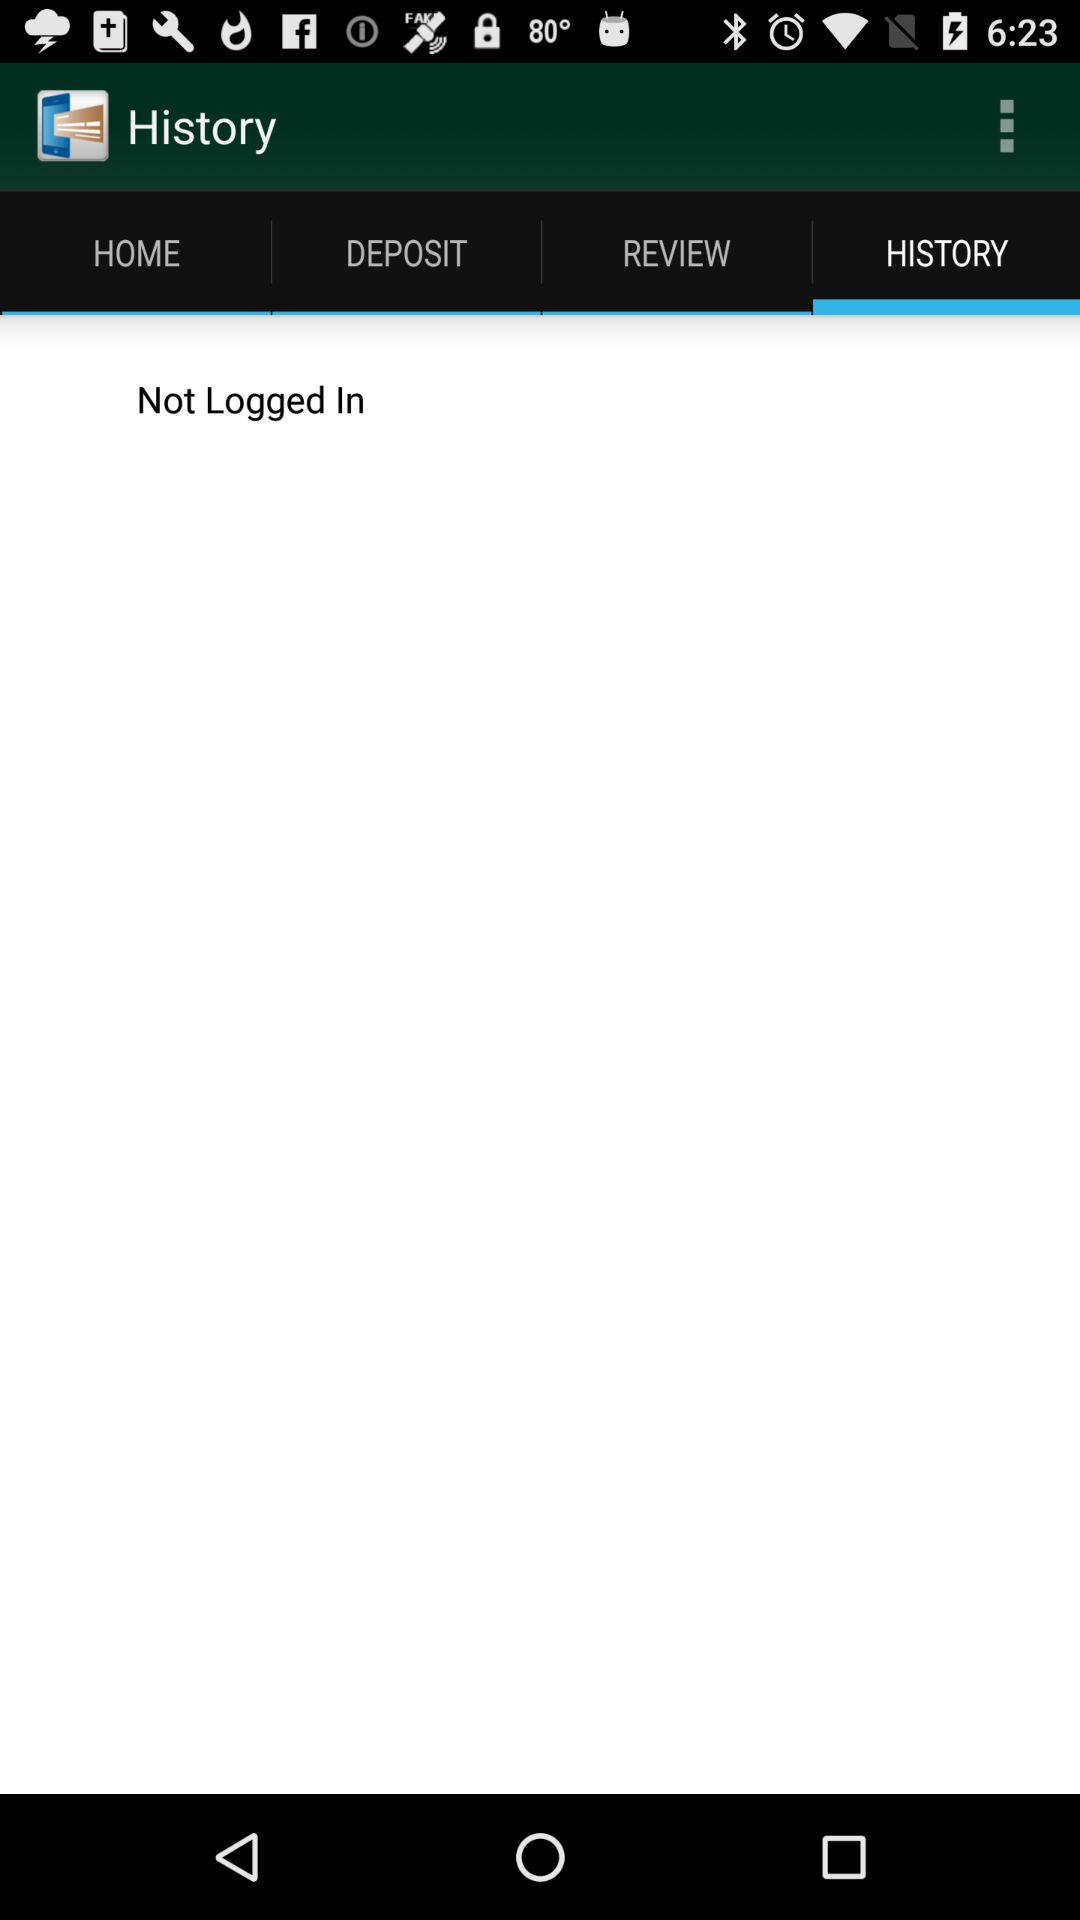Which tab is selected? The selected tab is "HISTORY". 